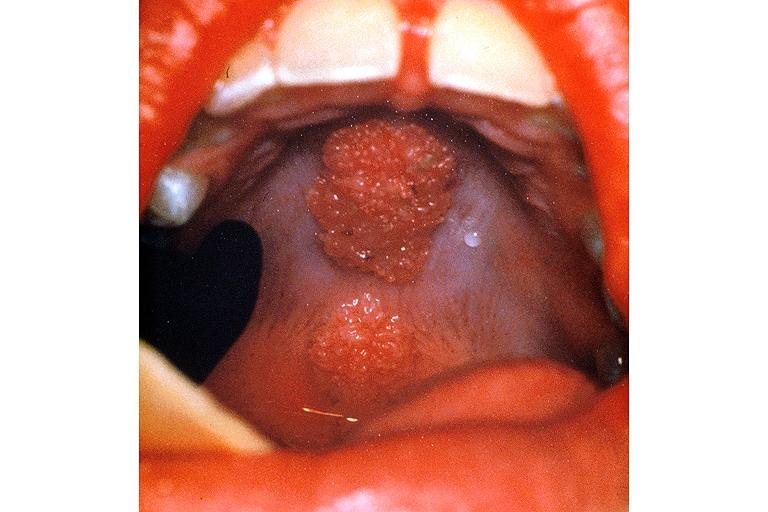does candida show condyloma accuminatum?
Answer the question using a single word or phrase. No 